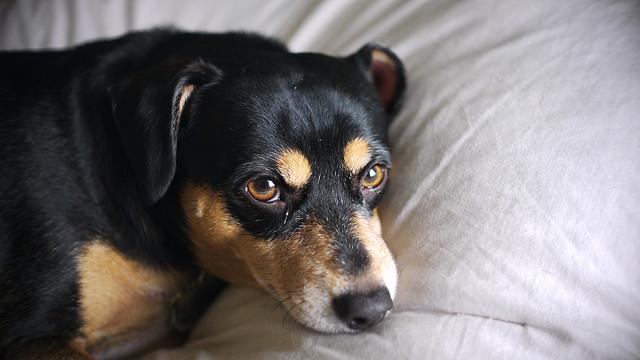What color eyes does the dog have?
Be succinct. Brown. Does this dog have brown eyes?
Give a very brief answer. Yes. What is the breed of dog?
Give a very brief answer. Beagle. Are the dog's ears erect?
Write a very short answer. No. 